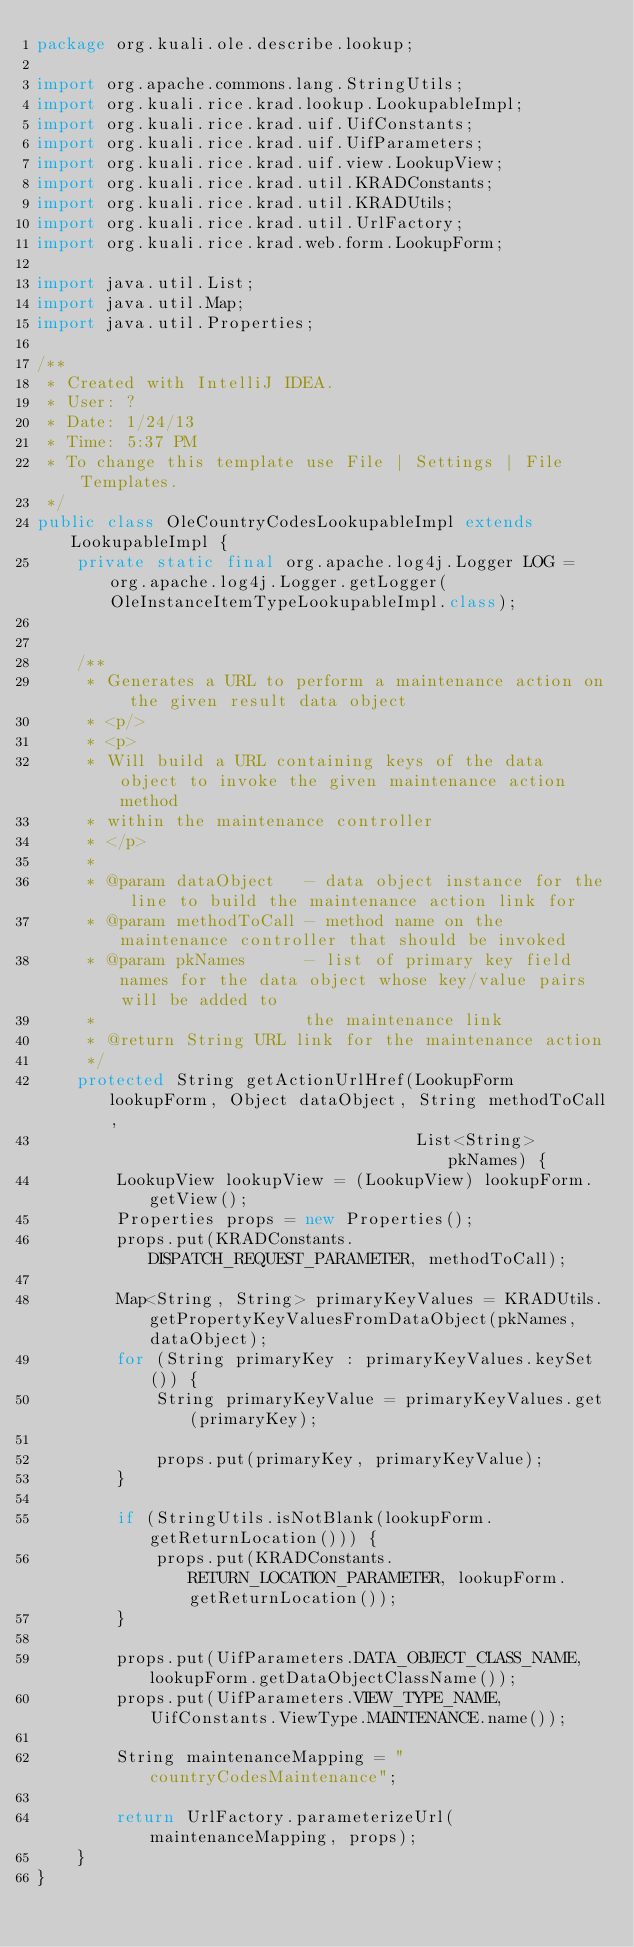<code> <loc_0><loc_0><loc_500><loc_500><_Java_>package org.kuali.ole.describe.lookup;

import org.apache.commons.lang.StringUtils;
import org.kuali.rice.krad.lookup.LookupableImpl;
import org.kuali.rice.krad.uif.UifConstants;
import org.kuali.rice.krad.uif.UifParameters;
import org.kuali.rice.krad.uif.view.LookupView;
import org.kuali.rice.krad.util.KRADConstants;
import org.kuali.rice.krad.util.KRADUtils;
import org.kuali.rice.krad.util.UrlFactory;
import org.kuali.rice.krad.web.form.LookupForm;

import java.util.List;
import java.util.Map;
import java.util.Properties;

/**
 * Created with IntelliJ IDEA.
 * User: ?
 * Date: 1/24/13
 * Time: 5:37 PM
 * To change this template use File | Settings | File Templates.
 */
public class OleCountryCodesLookupableImpl extends LookupableImpl {
    private static final org.apache.log4j.Logger LOG = org.apache.log4j.Logger.getLogger(OleInstanceItemTypeLookupableImpl.class);


    /**
     * Generates a URL to perform a maintenance action on the given result data object
     * <p/>
     * <p>
     * Will build a URL containing keys of the data object to invoke the given maintenance action method
     * within the maintenance controller
     * </p>
     *
     * @param dataObject   - data object instance for the line to build the maintenance action link for
     * @param methodToCall - method name on the maintenance controller that should be invoked
     * @param pkNames      - list of primary key field names for the data object whose key/value pairs will be added to
     *                     the maintenance link
     * @return String URL link for the maintenance action
     */
    protected String getActionUrlHref(LookupForm lookupForm, Object dataObject, String methodToCall,
                                      List<String> pkNames) {
        LookupView lookupView = (LookupView) lookupForm.getView();
        Properties props = new Properties();
        props.put(KRADConstants.DISPATCH_REQUEST_PARAMETER, methodToCall);

        Map<String, String> primaryKeyValues = KRADUtils.getPropertyKeyValuesFromDataObject(pkNames, dataObject);
        for (String primaryKey : primaryKeyValues.keySet()) {
            String primaryKeyValue = primaryKeyValues.get(primaryKey);

            props.put(primaryKey, primaryKeyValue);
        }

        if (StringUtils.isNotBlank(lookupForm.getReturnLocation())) {
            props.put(KRADConstants.RETURN_LOCATION_PARAMETER, lookupForm.getReturnLocation());
        }

        props.put(UifParameters.DATA_OBJECT_CLASS_NAME, lookupForm.getDataObjectClassName());
        props.put(UifParameters.VIEW_TYPE_NAME, UifConstants.ViewType.MAINTENANCE.name());

        String maintenanceMapping = "countryCodesMaintenance";

        return UrlFactory.parameterizeUrl(maintenanceMapping, props);
    }
}</code> 